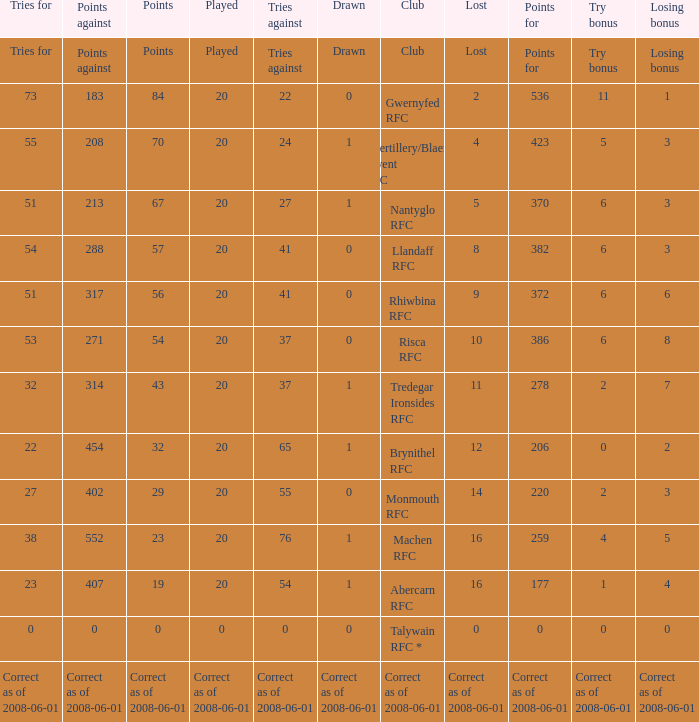If the points were 0, what were the tries for? 0.0. 